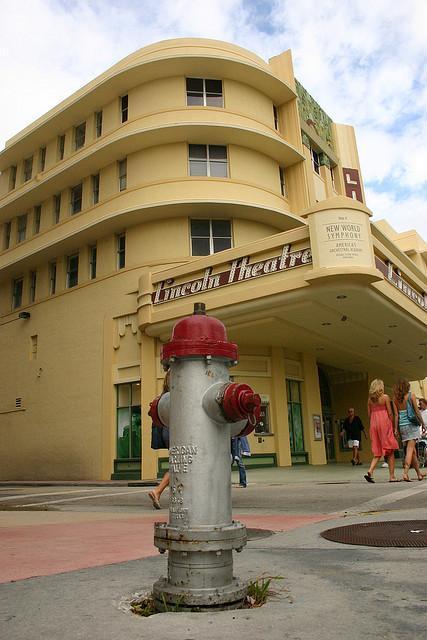How many people are there?
Give a very brief answer. 5. How many vehicles have surfboards on top of them?
Give a very brief answer. 0. 